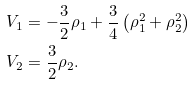Convert formula to latex. <formula><loc_0><loc_0><loc_500><loc_500>V _ { 1 } & = - \frac { 3 } { 2 } \rho _ { 1 } + \frac { 3 } { 4 } \left ( \rho _ { 1 } ^ { 2 } + \rho _ { 2 } ^ { 2 } \right ) \\ V _ { 2 } & = \frac { 3 } { 2 } \rho _ { 2 } .</formula> 